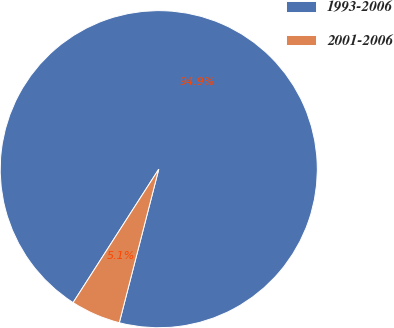Convert chart. <chart><loc_0><loc_0><loc_500><loc_500><pie_chart><fcel>1993-2006<fcel>2001-2006<nl><fcel>94.92%<fcel>5.08%<nl></chart> 